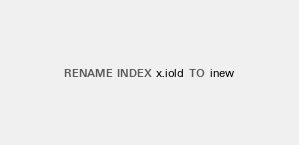Convert code to text. <code><loc_0><loc_0><loc_500><loc_500><_SQL_>RENAME INDEX x.iold TO inew
</code> 